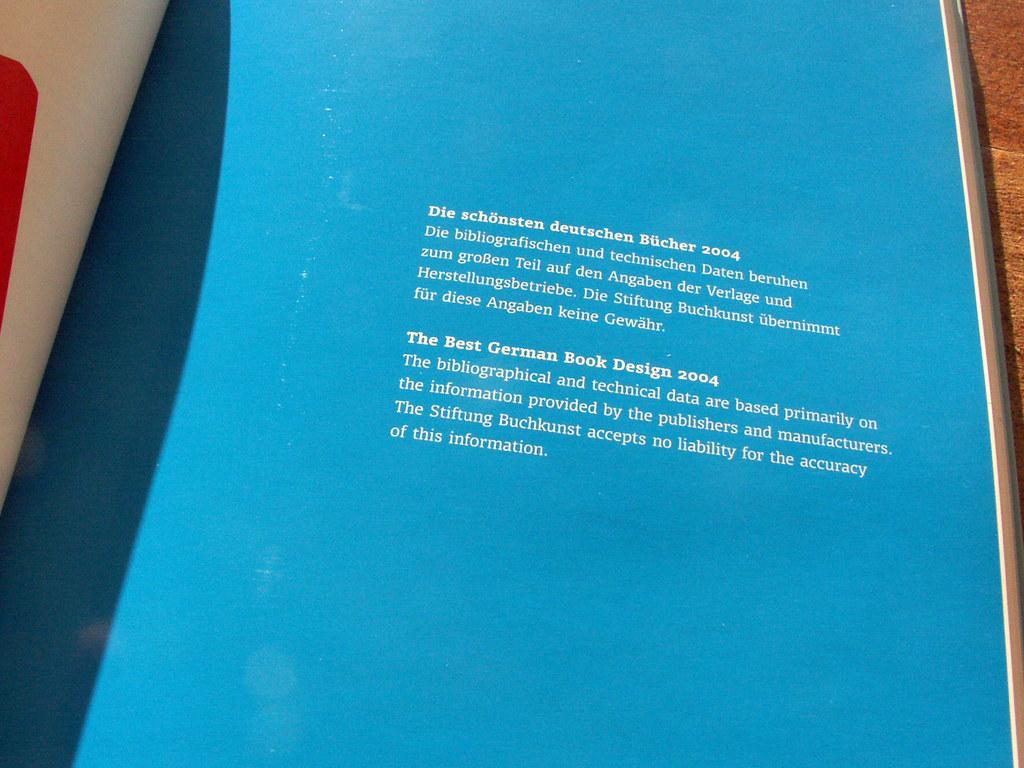What year was this written?
Your answer should be very brief. 2004. Is the information in this book reliable?
Provide a succinct answer. Unanswerable. 